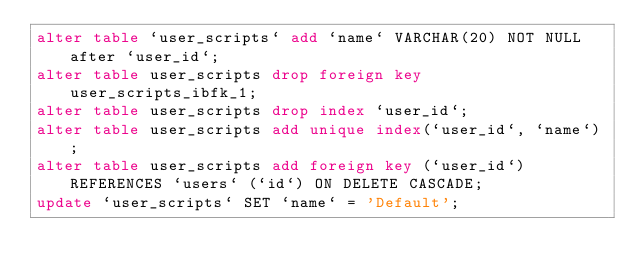<code> <loc_0><loc_0><loc_500><loc_500><_SQL_>alter table `user_scripts` add `name` VARCHAR(20) NOT NULL after `user_id`;
alter table user_scripts drop foreign key user_scripts_ibfk_1;
alter table user_scripts drop index `user_id`;
alter table user_scripts add unique index(`user_id`, `name`);
alter table user_scripts add foreign key (`user_id`) REFERENCES `users` (`id`) ON DELETE CASCADE;
update `user_scripts` SET `name` = 'Default';</code> 